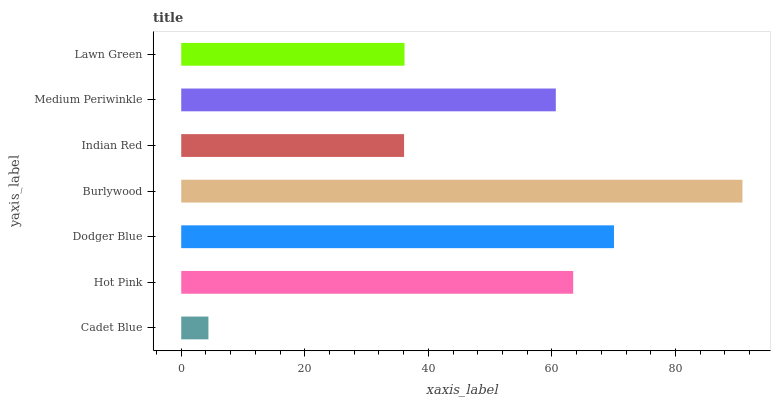Is Cadet Blue the minimum?
Answer yes or no. Yes. Is Burlywood the maximum?
Answer yes or no. Yes. Is Hot Pink the minimum?
Answer yes or no. No. Is Hot Pink the maximum?
Answer yes or no. No. Is Hot Pink greater than Cadet Blue?
Answer yes or no. Yes. Is Cadet Blue less than Hot Pink?
Answer yes or no. Yes. Is Cadet Blue greater than Hot Pink?
Answer yes or no. No. Is Hot Pink less than Cadet Blue?
Answer yes or no. No. Is Medium Periwinkle the high median?
Answer yes or no. Yes. Is Medium Periwinkle the low median?
Answer yes or no. Yes. Is Lawn Green the high median?
Answer yes or no. No. Is Hot Pink the low median?
Answer yes or no. No. 